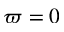<formula> <loc_0><loc_0><loc_500><loc_500>\varpi = 0</formula> 